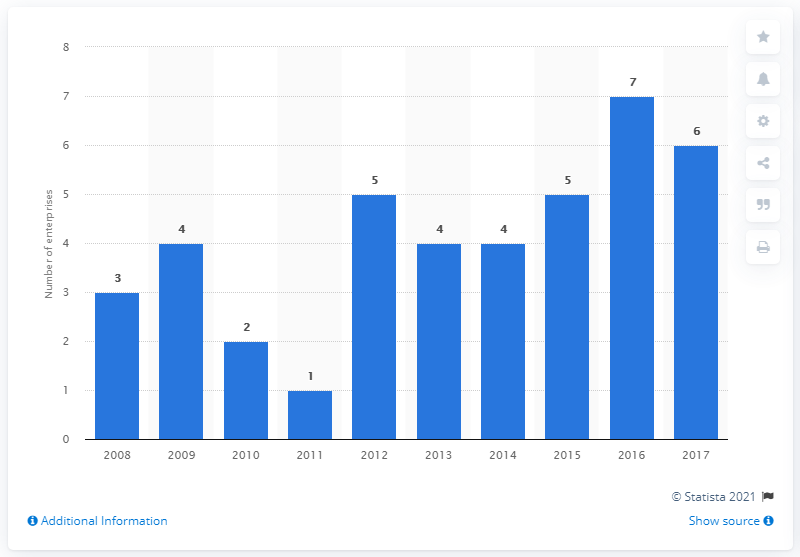Can you determine the year with the highest number of employees? The year with the highest number of employees, as depicted in this histogram, is 2017, with a count of 7. 